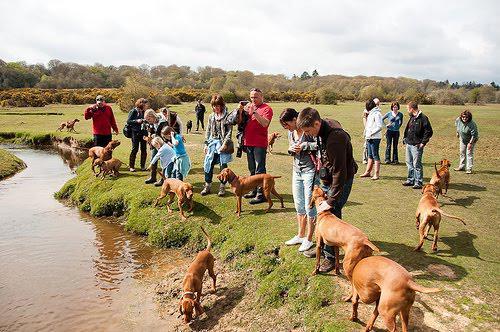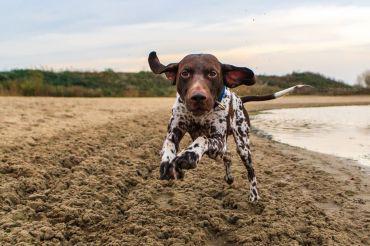The first image is the image on the left, the second image is the image on the right. Assess this claim about the two images: "A dog has at least one front paw off the ground.". Correct or not? Answer yes or no. Yes. The first image is the image on the left, the second image is the image on the right. Considering the images on both sides, is "The dog on the right is posed with a hunting weapon and a fowl, while the dog on the left has a very visible collar." valid? Answer yes or no. No. 